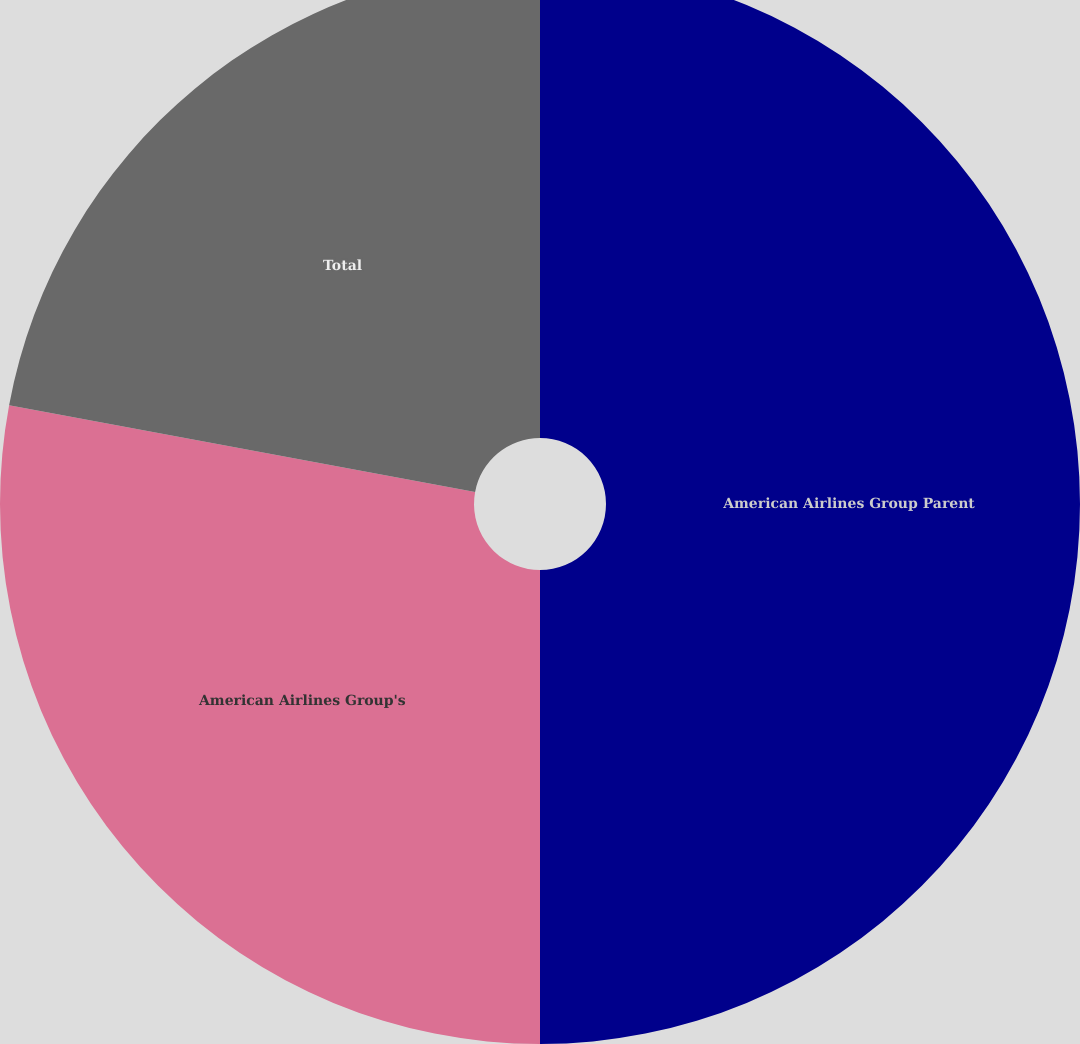<chart> <loc_0><loc_0><loc_500><loc_500><pie_chart><fcel>American Airlines Group Parent<fcel>American Airlines Group's<fcel>Total<nl><fcel>50.0%<fcel>27.93%<fcel>22.07%<nl></chart> 